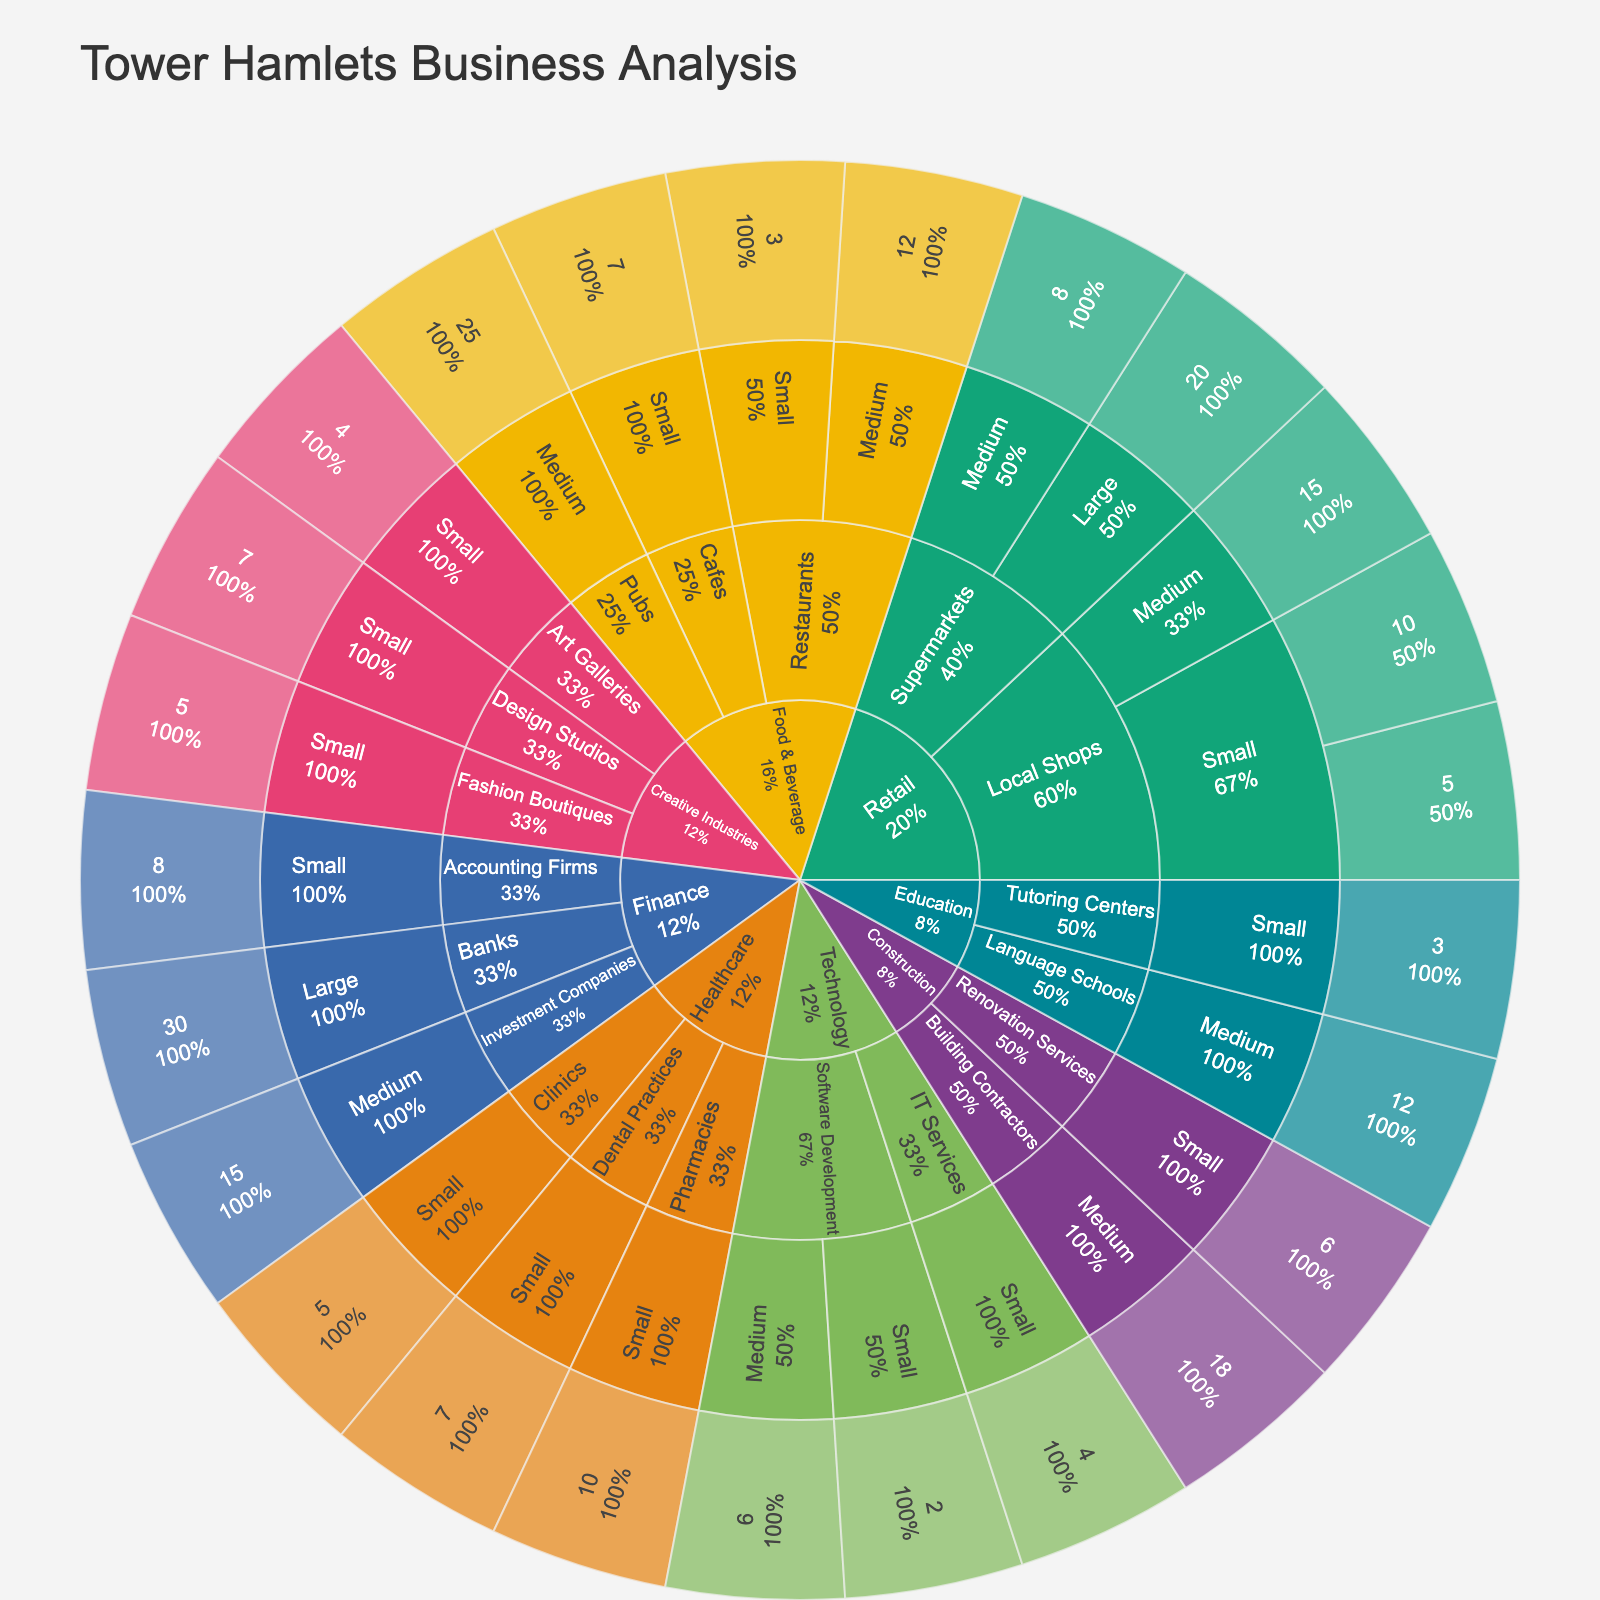What is the title of the plot? The title is usually positioned at the top of the plot and it describes the contents of the visualization.
Answer: Tower Hamlets Business Analysis Which industry has the largest number of businesses? To determine this, look for the largest segment at the first level of the sunburst plot. The larger the segment, the more businesses it represents.
Answer: Retail How many medium-sized sectors are there in the Retail industry? Navigate to the 'Retail' section in the plot and count the segments labeled as 'Medium'.
Answer: 2 Which industry sector has the largest number of operations with 10 years of operation? Navigate through the segments by 'years_of_operation' and check the size of the segments labeled '10' to identify the largest one.
Answer: Retail (Local Shops) What percentage of Food & Beverage businesses are restaurants? Calculate the percentage by comparing the size of the 'Restaurants' segment to the total Food & Beverage segment in the plot.
Answer: Roughly 44.4% How many sectors are in the Construction industry and what are they? Find the 'Construction' segment in the plot and count its child sectors, listing them.
Answer: 2 (Building Contractors, Renovation Services) Between the healthcare and education sectors, which one has a smaller number of businesses and by how much? Compare the segment sizes of 'Healthcare' and 'Education' to identify the smaller one, then calculate the difference in their sizes.
Answer: Education is smaller by 1 business Which sector in the Creative Industries has businesses with the longest years of operation, and what is the duration? Check the 'Creative Industries' sector and its child segments for the one with the highest 'years_of_operation' label.
Answer: Design Studios, 7 years What is the most common size for businesses in the Technology industry? Check the 'Technology' section and identify the size segment that appears most frequently.
Answer: Small Compare the number of segments showing years of operation equal to or greater than 10 years in the Finance and Retail industries. Which one has more, and by how many? Navigate through the 'Finance' and 'Retail' sections and count the segments with 'years_of_operation' >= 10 years, then compare the totals.
Answer: Retail has more by 1 segment 